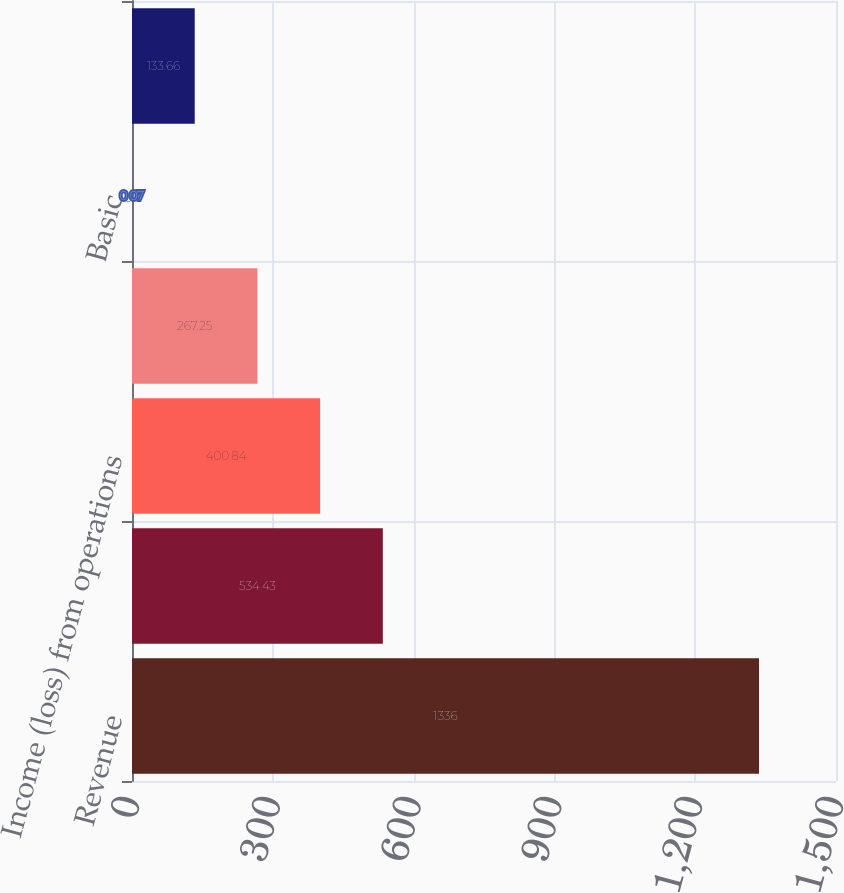Convert chart. <chart><loc_0><loc_0><loc_500><loc_500><bar_chart><fcel>Revenue<fcel>Gross margin<fcel>Income (loss) from operations<fcel>Net income (loss)<fcel>Basic<fcel>Diluted<nl><fcel>1336<fcel>534.43<fcel>400.84<fcel>267.25<fcel>0.07<fcel>133.66<nl></chart> 